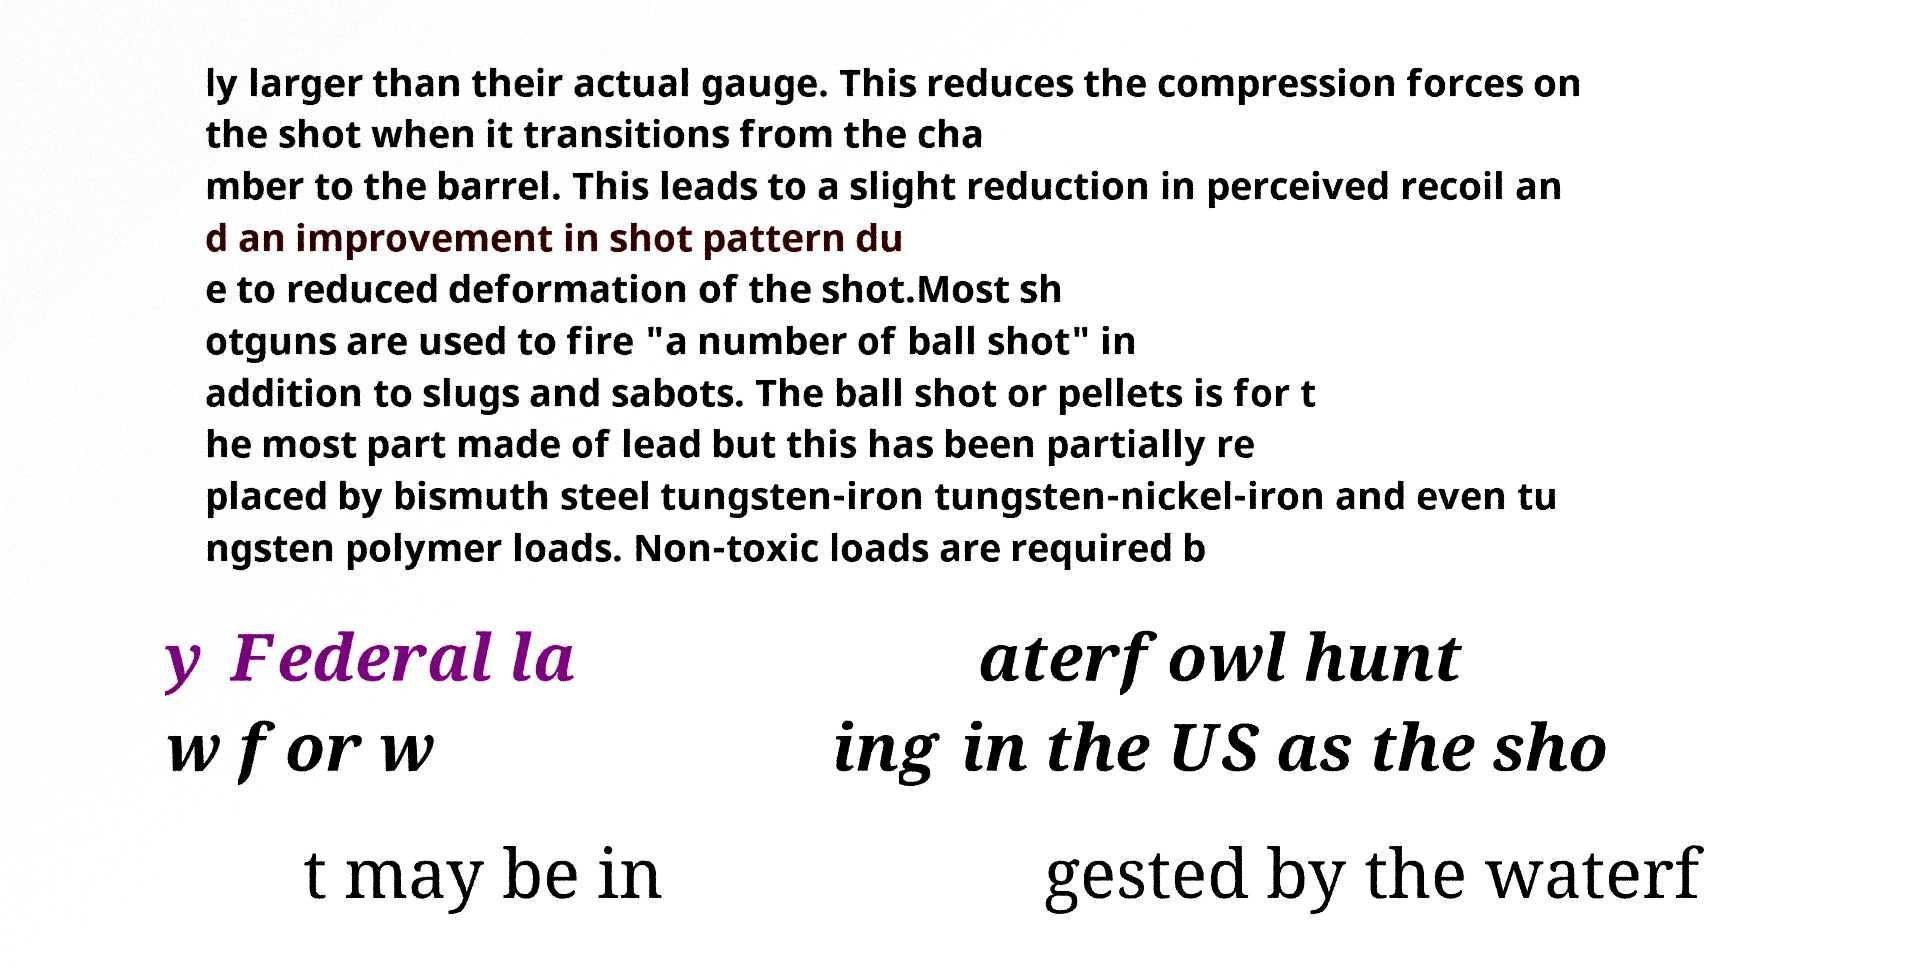Can you accurately transcribe the text from the provided image for me? ly larger than their actual gauge. This reduces the compression forces on the shot when it transitions from the cha mber to the barrel. This leads to a slight reduction in perceived recoil an d an improvement in shot pattern du e to reduced deformation of the shot.Most sh otguns are used to fire "a number of ball shot" in addition to slugs and sabots. The ball shot or pellets is for t he most part made of lead but this has been partially re placed by bismuth steel tungsten-iron tungsten-nickel-iron and even tu ngsten polymer loads. Non-toxic loads are required b y Federal la w for w aterfowl hunt ing in the US as the sho t may be in gested by the waterf 